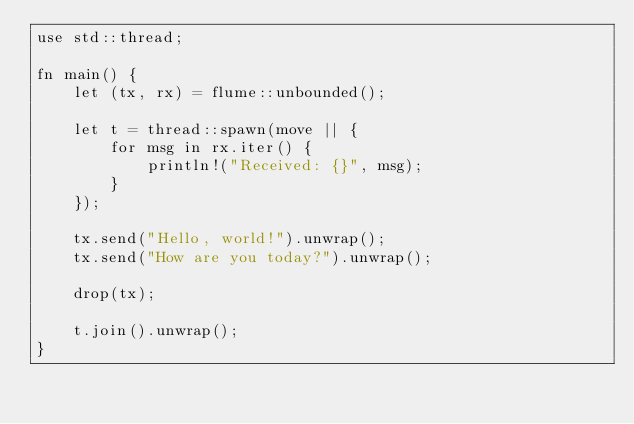Convert code to text. <code><loc_0><loc_0><loc_500><loc_500><_Rust_>use std::thread;

fn main() {
    let (tx, rx) = flume::unbounded();

    let t = thread::spawn(move || {
        for msg in rx.iter() {
            println!("Received: {}", msg);
        }
    });

    tx.send("Hello, world!").unwrap();
    tx.send("How are you today?").unwrap();

    drop(tx);

    t.join().unwrap();
}
</code> 